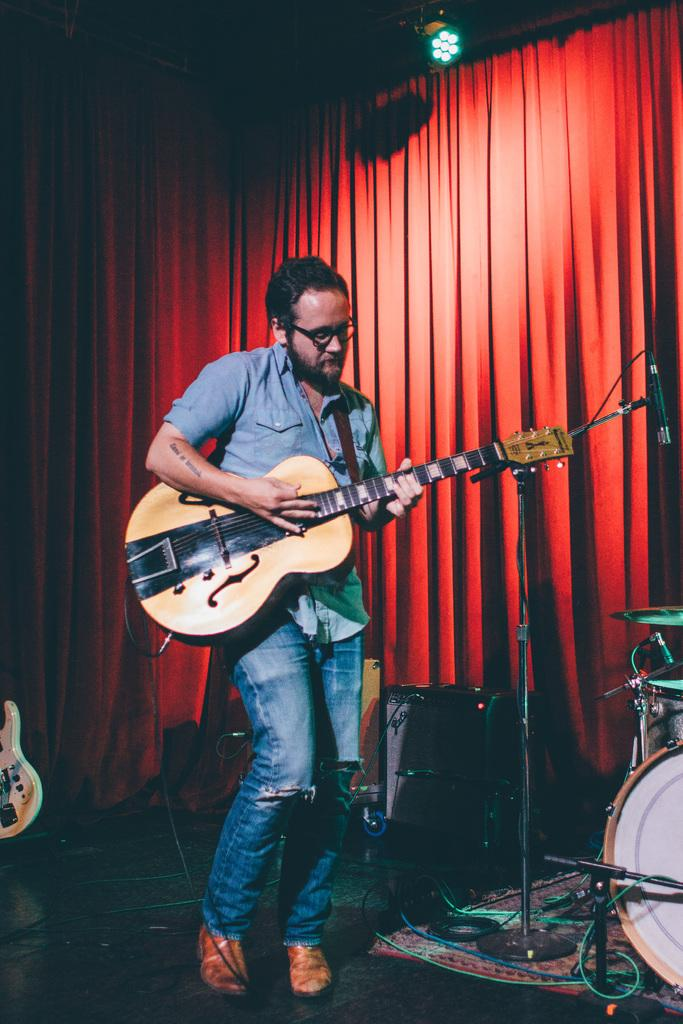What is the main subject of the image? There is a man in the image. What is the man doing in the image? The man is playing a guitar. What type of hook is the man using to play the guitar in the image? There is no hook present in the image; the man is playing the guitar with his hands. What is the man's state of mind while playing the guitar in the image? The image does not provide information about the man's state of mind, so we cannot determine his emotions or thoughts. 